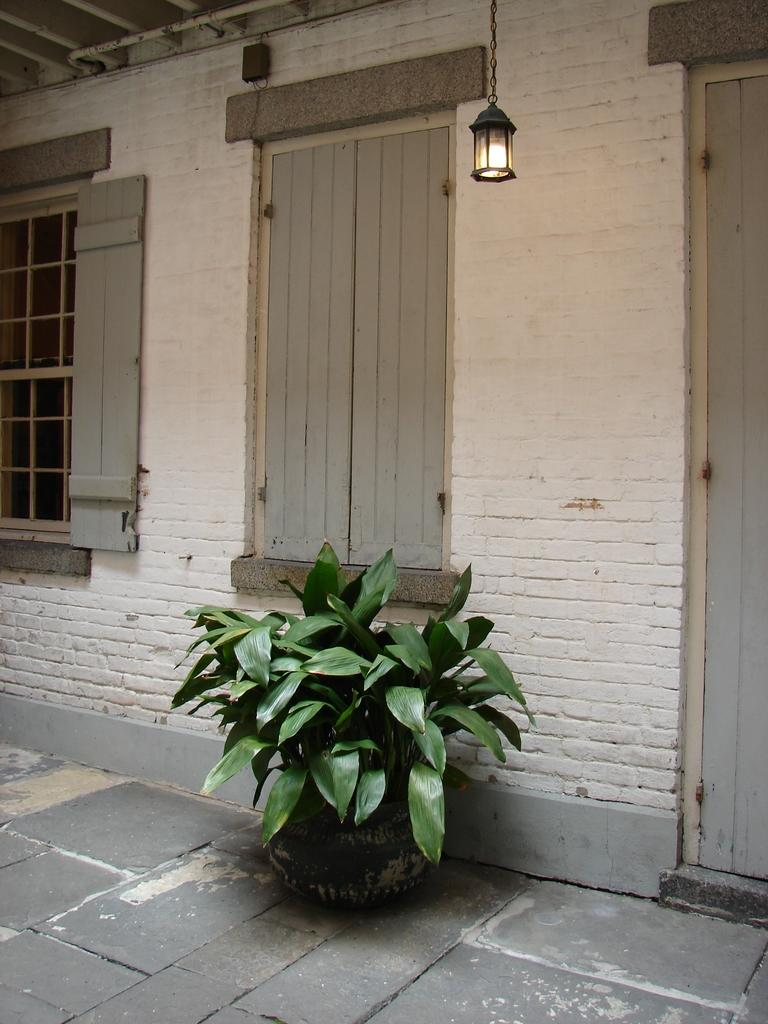What is present in the image? There is a plant in the image. Can you describe the color of the plant? The plant is green. What can be seen in the background of the image? There are windows and a lamp in the background of the image. What color is the wall in the background? The wall in the background is white. What type of game is being played in the image? There is no game present in the image; it features a plant and background elements. How many planes can be seen flying in the image? There are no planes visible in the image. 